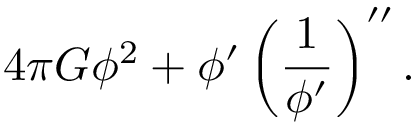Convert formula to latex. <formula><loc_0><loc_0><loc_500><loc_500>{ 4 \pi G } \phi ^ { 2 } + \phi ^ { \prime } \left ( { \frac { 1 } { \phi ^ { \prime } } } \right ) ^ { \prime \prime } .</formula> 